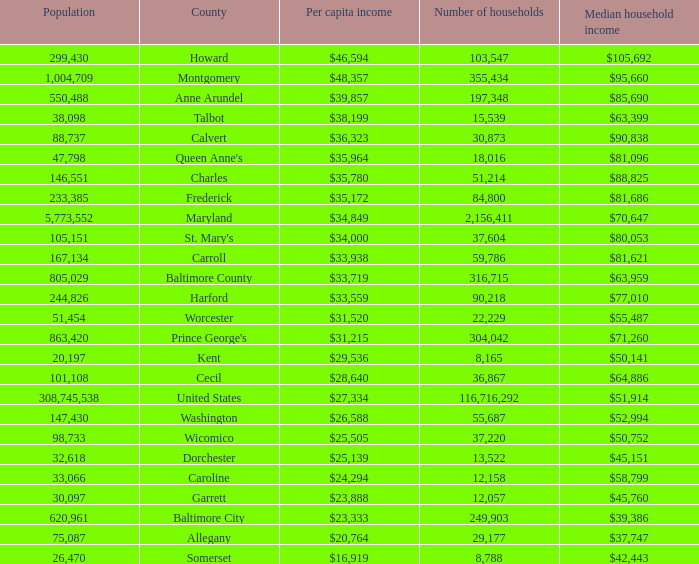What is the per capital income for Charles county? $35,780. 